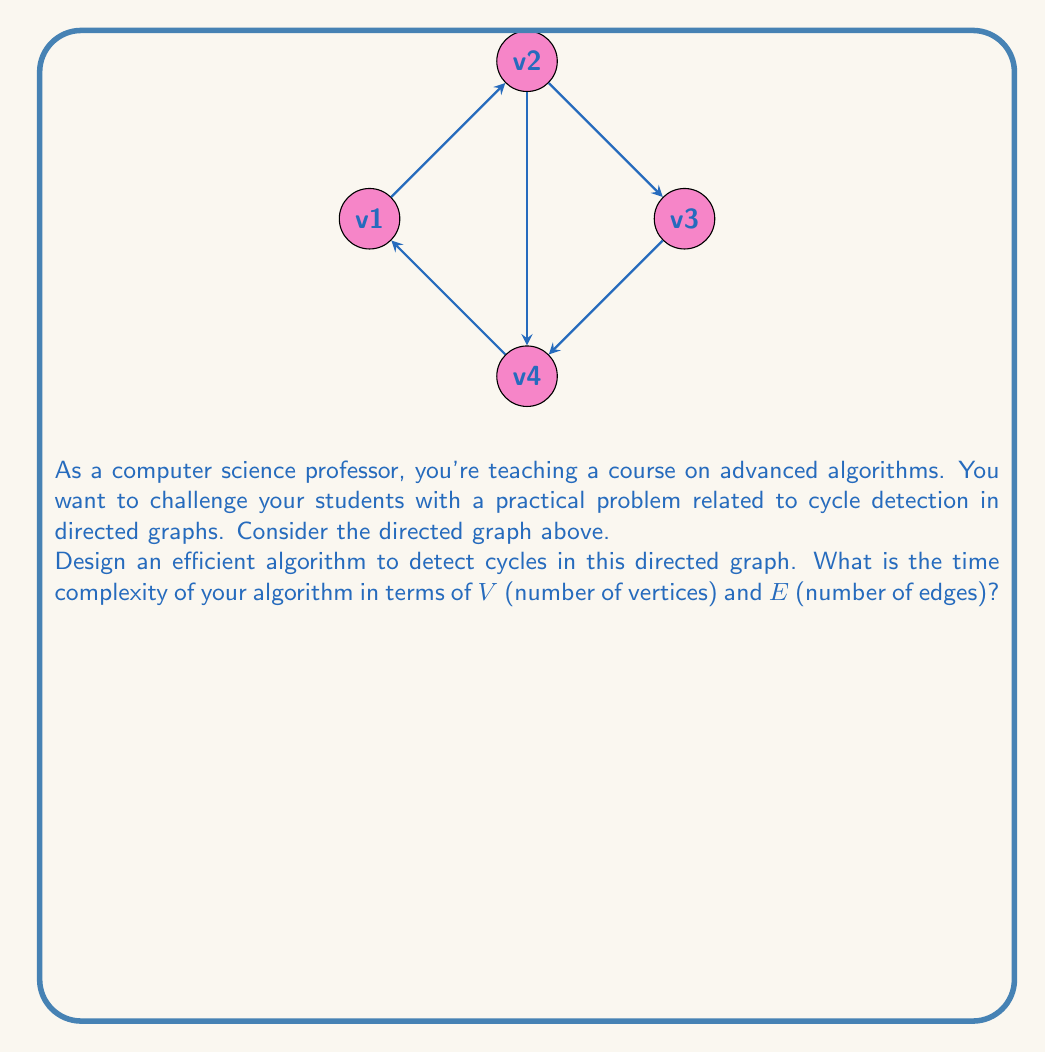Can you answer this question? To detect cycles in a directed graph efficiently, we can use a Depth-First Search (DFS) based algorithm. Here's a step-by-step explanation:

1. Initialize three sets:
   - $white$: All vertices (unvisited)
   - $gray$: Vertices currently in the DFS stack (being visited)
   - $black$: Vertices that have been completely visited

2. For each vertex in the $white$ set:
   a. If the vertex is in $white$, call DFS on it.
   b. In the DFS function:
      - Move the current vertex from $white$ to $gray$.
      - For each adjacent vertex:
        * If it's in $gray$, we've found a cycle. Return true.
        * If it's in $white$, recursively call DFS on it.
      - After exploring all adjacent vertices, move the current vertex from $gray$ to $black$.

3. If no cycle is found after exploring all vertices, return false.

The time complexity analysis:
- Each vertex is processed once: $O(V)$
- Each edge is considered once: $O(E)$

Therefore, the overall time complexity is $O(V + E)$.

In the worst case, when the graph is densely connected, $E$ could be $O(V^2)$, making the time complexity $O(V^2)$. However, for sparse graphs, this algorithm is very efficient.

For the given graph:
- Vertices: $v_1$, $v_2$, $v_3$, $v_4$
- Edges: $(v_1,v_2)$, $(v_2,v_3)$, $(v_3,v_4)$, $(v_4,v_1)$, $(v_2,v_4)$

The algorithm would detect the cycle: $v_1 \rightarrow v_2 \rightarrow v_3 \rightarrow v_4 \rightarrow v_1$
Answer: $O(V + E)$ 